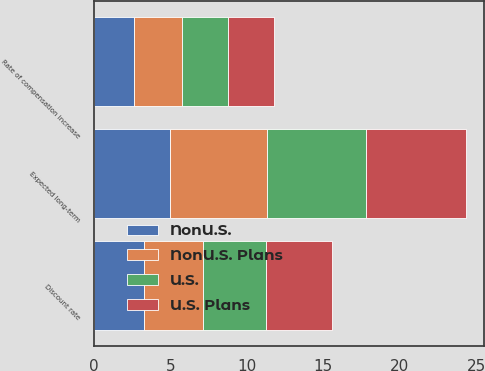Convert chart to OTSL. <chart><loc_0><loc_0><loc_500><loc_500><stacked_bar_chart><ecel><fcel>Discount rate<fcel>Rate of compensation increase<fcel>Expected long-term<nl><fcel>U.S.<fcel>4.09<fcel>3<fcel>6.5<nl><fcel>NonU.S.<fcel>3.26<fcel>2.65<fcel>4.98<nl><fcel>U.S. Plans<fcel>4.3<fcel>3<fcel>6.5<nl><fcel>NonU.S. Plans<fcel>3.89<fcel>3.1<fcel>6.34<nl></chart> 